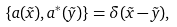Convert formula to latex. <formula><loc_0><loc_0><loc_500><loc_500>\left \{ a ( \vec { x } ) , a ^ { * } ( \vec { y } ) \right \} = \delta ( \vec { x } - \vec { y } ) , \quad</formula> 